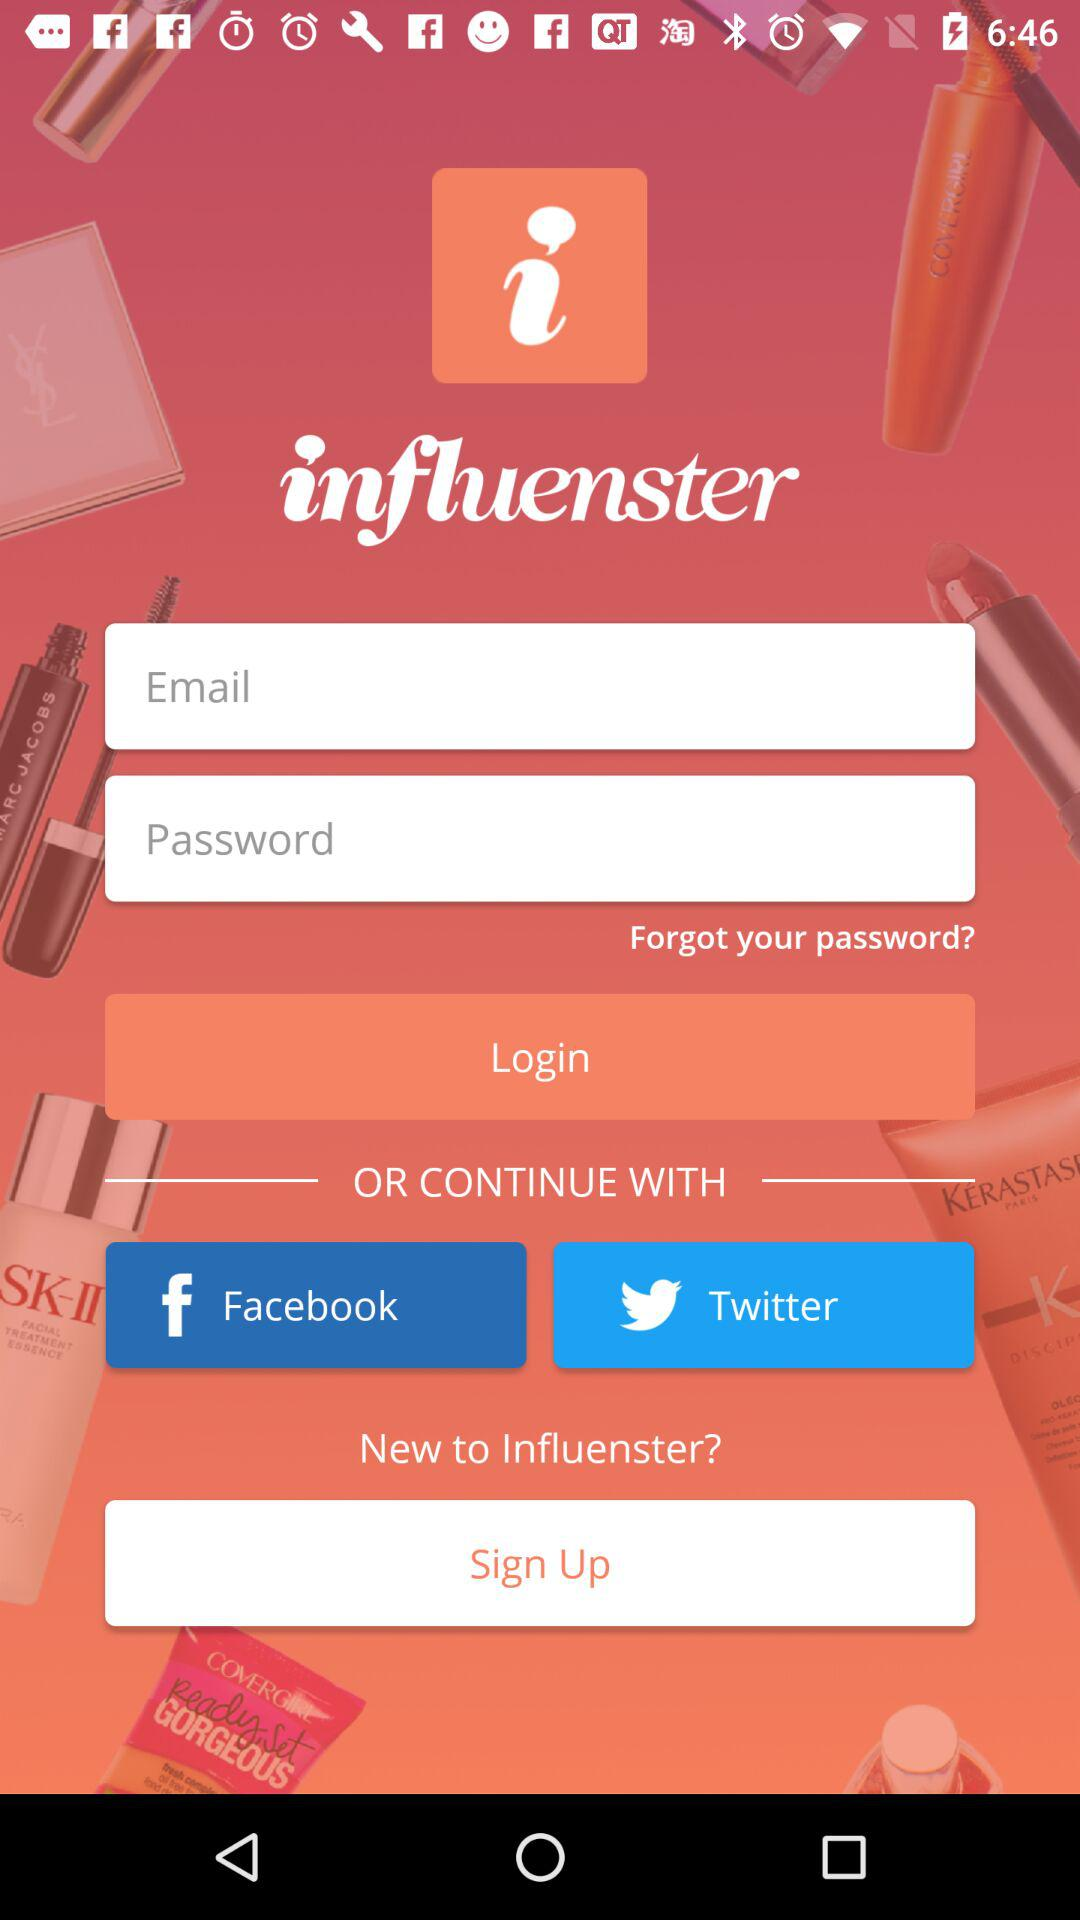What are the different options available for sign up?
When the provided information is insufficient, respond with <no answer>. <no answer> 